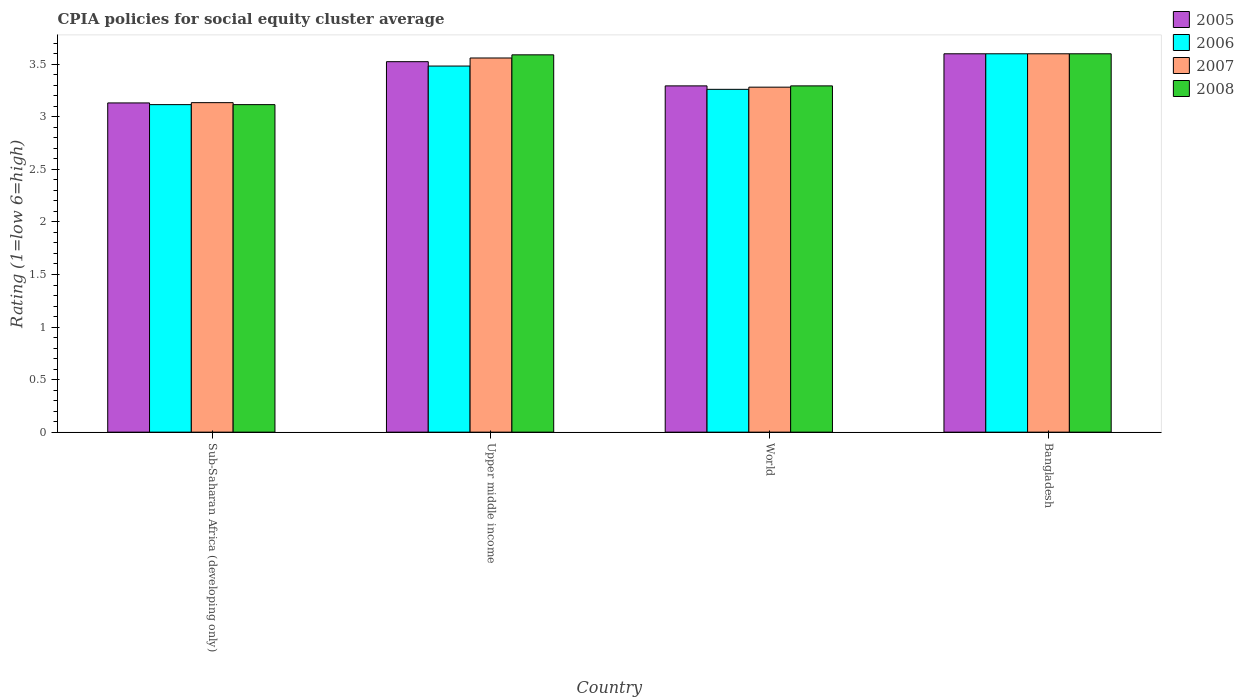How many different coloured bars are there?
Ensure brevity in your answer.  4. How many bars are there on the 4th tick from the left?
Ensure brevity in your answer.  4. How many bars are there on the 2nd tick from the right?
Give a very brief answer. 4. What is the label of the 2nd group of bars from the left?
Offer a terse response. Upper middle income. In how many cases, is the number of bars for a given country not equal to the number of legend labels?
Give a very brief answer. 0. What is the CPIA rating in 2006 in Sub-Saharan Africa (developing only)?
Make the answer very short. 3.12. Across all countries, what is the minimum CPIA rating in 2005?
Ensure brevity in your answer.  3.13. In which country was the CPIA rating in 2008 maximum?
Your response must be concise. Bangladesh. In which country was the CPIA rating in 2005 minimum?
Provide a short and direct response. Sub-Saharan Africa (developing only). What is the total CPIA rating in 2008 in the graph?
Give a very brief answer. 13.6. What is the difference between the CPIA rating in 2006 in Sub-Saharan Africa (developing only) and that in World?
Offer a terse response. -0.15. What is the difference between the CPIA rating in 2008 in World and the CPIA rating in 2006 in Sub-Saharan Africa (developing only)?
Offer a very short reply. 0.18. What is the average CPIA rating in 2006 per country?
Keep it short and to the point. 3.37. What is the difference between the CPIA rating of/in 2007 and CPIA rating of/in 2006 in World?
Offer a very short reply. 0.02. What is the ratio of the CPIA rating in 2007 in Sub-Saharan Africa (developing only) to that in World?
Offer a terse response. 0.96. Is the CPIA rating in 2007 in Bangladesh less than that in World?
Your response must be concise. No. Is the difference between the CPIA rating in 2007 in Bangladesh and Sub-Saharan Africa (developing only) greater than the difference between the CPIA rating in 2006 in Bangladesh and Sub-Saharan Africa (developing only)?
Keep it short and to the point. No. What is the difference between the highest and the second highest CPIA rating in 2005?
Make the answer very short. -0.08. What is the difference between the highest and the lowest CPIA rating in 2006?
Provide a succinct answer. 0.48. In how many countries, is the CPIA rating in 2005 greater than the average CPIA rating in 2005 taken over all countries?
Make the answer very short. 2. What does the 1st bar from the right in Bangladesh represents?
Provide a short and direct response. 2008. Is it the case that in every country, the sum of the CPIA rating in 2005 and CPIA rating in 2007 is greater than the CPIA rating in 2006?
Provide a succinct answer. Yes. How many countries are there in the graph?
Provide a succinct answer. 4. Does the graph contain grids?
Offer a terse response. No. Where does the legend appear in the graph?
Your response must be concise. Top right. How many legend labels are there?
Make the answer very short. 4. How are the legend labels stacked?
Your response must be concise. Vertical. What is the title of the graph?
Your answer should be very brief. CPIA policies for social equity cluster average. Does "1962" appear as one of the legend labels in the graph?
Offer a terse response. No. What is the Rating (1=low 6=high) of 2005 in Sub-Saharan Africa (developing only)?
Keep it short and to the point. 3.13. What is the Rating (1=low 6=high) in 2006 in Sub-Saharan Africa (developing only)?
Provide a succinct answer. 3.12. What is the Rating (1=low 6=high) of 2007 in Sub-Saharan Africa (developing only)?
Your response must be concise. 3.14. What is the Rating (1=low 6=high) in 2008 in Sub-Saharan Africa (developing only)?
Offer a terse response. 3.12. What is the Rating (1=low 6=high) in 2005 in Upper middle income?
Keep it short and to the point. 3.52. What is the Rating (1=low 6=high) of 2006 in Upper middle income?
Your answer should be compact. 3.48. What is the Rating (1=low 6=high) in 2007 in Upper middle income?
Provide a succinct answer. 3.56. What is the Rating (1=low 6=high) in 2008 in Upper middle income?
Offer a very short reply. 3.59. What is the Rating (1=low 6=high) in 2005 in World?
Your answer should be very brief. 3.29. What is the Rating (1=low 6=high) in 2006 in World?
Your answer should be compact. 3.26. What is the Rating (1=low 6=high) of 2007 in World?
Your answer should be compact. 3.28. What is the Rating (1=low 6=high) of 2008 in World?
Your response must be concise. 3.29. Across all countries, what is the maximum Rating (1=low 6=high) in 2005?
Ensure brevity in your answer.  3.6. Across all countries, what is the maximum Rating (1=low 6=high) of 2008?
Your response must be concise. 3.6. Across all countries, what is the minimum Rating (1=low 6=high) of 2005?
Offer a very short reply. 3.13. Across all countries, what is the minimum Rating (1=low 6=high) of 2006?
Keep it short and to the point. 3.12. Across all countries, what is the minimum Rating (1=low 6=high) of 2007?
Keep it short and to the point. 3.14. Across all countries, what is the minimum Rating (1=low 6=high) of 2008?
Provide a succinct answer. 3.12. What is the total Rating (1=low 6=high) of 2005 in the graph?
Offer a very short reply. 13.55. What is the total Rating (1=low 6=high) of 2006 in the graph?
Offer a terse response. 13.46. What is the total Rating (1=low 6=high) in 2007 in the graph?
Your response must be concise. 13.58. What is the total Rating (1=low 6=high) in 2008 in the graph?
Provide a short and direct response. 13.6. What is the difference between the Rating (1=low 6=high) in 2005 in Sub-Saharan Africa (developing only) and that in Upper middle income?
Ensure brevity in your answer.  -0.39. What is the difference between the Rating (1=low 6=high) in 2006 in Sub-Saharan Africa (developing only) and that in Upper middle income?
Your answer should be compact. -0.37. What is the difference between the Rating (1=low 6=high) of 2007 in Sub-Saharan Africa (developing only) and that in Upper middle income?
Your answer should be very brief. -0.42. What is the difference between the Rating (1=low 6=high) of 2008 in Sub-Saharan Africa (developing only) and that in Upper middle income?
Give a very brief answer. -0.47. What is the difference between the Rating (1=low 6=high) in 2005 in Sub-Saharan Africa (developing only) and that in World?
Ensure brevity in your answer.  -0.16. What is the difference between the Rating (1=low 6=high) of 2006 in Sub-Saharan Africa (developing only) and that in World?
Make the answer very short. -0.15. What is the difference between the Rating (1=low 6=high) in 2007 in Sub-Saharan Africa (developing only) and that in World?
Keep it short and to the point. -0.15. What is the difference between the Rating (1=low 6=high) of 2008 in Sub-Saharan Africa (developing only) and that in World?
Offer a terse response. -0.18. What is the difference between the Rating (1=low 6=high) in 2005 in Sub-Saharan Africa (developing only) and that in Bangladesh?
Your answer should be very brief. -0.47. What is the difference between the Rating (1=low 6=high) of 2006 in Sub-Saharan Africa (developing only) and that in Bangladesh?
Give a very brief answer. -0.48. What is the difference between the Rating (1=low 6=high) in 2007 in Sub-Saharan Africa (developing only) and that in Bangladesh?
Give a very brief answer. -0.46. What is the difference between the Rating (1=low 6=high) of 2008 in Sub-Saharan Africa (developing only) and that in Bangladesh?
Offer a terse response. -0.48. What is the difference between the Rating (1=low 6=high) of 2005 in Upper middle income and that in World?
Provide a succinct answer. 0.23. What is the difference between the Rating (1=low 6=high) of 2006 in Upper middle income and that in World?
Your response must be concise. 0.22. What is the difference between the Rating (1=low 6=high) in 2007 in Upper middle income and that in World?
Provide a short and direct response. 0.28. What is the difference between the Rating (1=low 6=high) of 2008 in Upper middle income and that in World?
Provide a succinct answer. 0.3. What is the difference between the Rating (1=low 6=high) in 2005 in Upper middle income and that in Bangladesh?
Your answer should be very brief. -0.07. What is the difference between the Rating (1=low 6=high) in 2006 in Upper middle income and that in Bangladesh?
Offer a very short reply. -0.12. What is the difference between the Rating (1=low 6=high) in 2007 in Upper middle income and that in Bangladesh?
Your answer should be compact. -0.04. What is the difference between the Rating (1=low 6=high) of 2008 in Upper middle income and that in Bangladesh?
Your response must be concise. -0.01. What is the difference between the Rating (1=low 6=high) in 2005 in World and that in Bangladesh?
Your answer should be compact. -0.31. What is the difference between the Rating (1=low 6=high) in 2006 in World and that in Bangladesh?
Offer a very short reply. -0.34. What is the difference between the Rating (1=low 6=high) in 2007 in World and that in Bangladesh?
Your answer should be compact. -0.32. What is the difference between the Rating (1=low 6=high) in 2008 in World and that in Bangladesh?
Make the answer very short. -0.31. What is the difference between the Rating (1=low 6=high) of 2005 in Sub-Saharan Africa (developing only) and the Rating (1=low 6=high) of 2006 in Upper middle income?
Offer a very short reply. -0.35. What is the difference between the Rating (1=low 6=high) in 2005 in Sub-Saharan Africa (developing only) and the Rating (1=low 6=high) in 2007 in Upper middle income?
Ensure brevity in your answer.  -0.43. What is the difference between the Rating (1=low 6=high) in 2005 in Sub-Saharan Africa (developing only) and the Rating (1=low 6=high) in 2008 in Upper middle income?
Ensure brevity in your answer.  -0.46. What is the difference between the Rating (1=low 6=high) in 2006 in Sub-Saharan Africa (developing only) and the Rating (1=low 6=high) in 2007 in Upper middle income?
Offer a terse response. -0.44. What is the difference between the Rating (1=low 6=high) of 2006 in Sub-Saharan Africa (developing only) and the Rating (1=low 6=high) of 2008 in Upper middle income?
Your answer should be compact. -0.47. What is the difference between the Rating (1=low 6=high) of 2007 in Sub-Saharan Africa (developing only) and the Rating (1=low 6=high) of 2008 in Upper middle income?
Offer a terse response. -0.45. What is the difference between the Rating (1=low 6=high) of 2005 in Sub-Saharan Africa (developing only) and the Rating (1=low 6=high) of 2006 in World?
Your answer should be very brief. -0.13. What is the difference between the Rating (1=low 6=high) of 2005 in Sub-Saharan Africa (developing only) and the Rating (1=low 6=high) of 2007 in World?
Ensure brevity in your answer.  -0.15. What is the difference between the Rating (1=low 6=high) of 2005 in Sub-Saharan Africa (developing only) and the Rating (1=low 6=high) of 2008 in World?
Offer a terse response. -0.16. What is the difference between the Rating (1=low 6=high) of 2006 in Sub-Saharan Africa (developing only) and the Rating (1=low 6=high) of 2007 in World?
Ensure brevity in your answer.  -0.17. What is the difference between the Rating (1=low 6=high) of 2006 in Sub-Saharan Africa (developing only) and the Rating (1=low 6=high) of 2008 in World?
Ensure brevity in your answer.  -0.18. What is the difference between the Rating (1=low 6=high) of 2007 in Sub-Saharan Africa (developing only) and the Rating (1=low 6=high) of 2008 in World?
Give a very brief answer. -0.16. What is the difference between the Rating (1=low 6=high) of 2005 in Sub-Saharan Africa (developing only) and the Rating (1=low 6=high) of 2006 in Bangladesh?
Ensure brevity in your answer.  -0.47. What is the difference between the Rating (1=low 6=high) of 2005 in Sub-Saharan Africa (developing only) and the Rating (1=low 6=high) of 2007 in Bangladesh?
Offer a very short reply. -0.47. What is the difference between the Rating (1=low 6=high) in 2005 in Sub-Saharan Africa (developing only) and the Rating (1=low 6=high) in 2008 in Bangladesh?
Offer a terse response. -0.47. What is the difference between the Rating (1=low 6=high) of 2006 in Sub-Saharan Africa (developing only) and the Rating (1=low 6=high) of 2007 in Bangladesh?
Keep it short and to the point. -0.48. What is the difference between the Rating (1=low 6=high) in 2006 in Sub-Saharan Africa (developing only) and the Rating (1=low 6=high) in 2008 in Bangladesh?
Offer a terse response. -0.48. What is the difference between the Rating (1=low 6=high) of 2007 in Sub-Saharan Africa (developing only) and the Rating (1=low 6=high) of 2008 in Bangladesh?
Make the answer very short. -0.46. What is the difference between the Rating (1=low 6=high) in 2005 in Upper middle income and the Rating (1=low 6=high) in 2006 in World?
Offer a very short reply. 0.26. What is the difference between the Rating (1=low 6=high) in 2005 in Upper middle income and the Rating (1=low 6=high) in 2007 in World?
Offer a terse response. 0.24. What is the difference between the Rating (1=low 6=high) of 2005 in Upper middle income and the Rating (1=low 6=high) of 2008 in World?
Your response must be concise. 0.23. What is the difference between the Rating (1=low 6=high) of 2006 in Upper middle income and the Rating (1=low 6=high) of 2007 in World?
Keep it short and to the point. 0.2. What is the difference between the Rating (1=low 6=high) of 2006 in Upper middle income and the Rating (1=low 6=high) of 2008 in World?
Ensure brevity in your answer.  0.19. What is the difference between the Rating (1=low 6=high) in 2007 in Upper middle income and the Rating (1=low 6=high) in 2008 in World?
Ensure brevity in your answer.  0.27. What is the difference between the Rating (1=low 6=high) of 2005 in Upper middle income and the Rating (1=low 6=high) of 2006 in Bangladesh?
Ensure brevity in your answer.  -0.07. What is the difference between the Rating (1=low 6=high) of 2005 in Upper middle income and the Rating (1=low 6=high) of 2007 in Bangladesh?
Give a very brief answer. -0.07. What is the difference between the Rating (1=low 6=high) of 2005 in Upper middle income and the Rating (1=low 6=high) of 2008 in Bangladesh?
Your answer should be compact. -0.07. What is the difference between the Rating (1=low 6=high) in 2006 in Upper middle income and the Rating (1=low 6=high) in 2007 in Bangladesh?
Your response must be concise. -0.12. What is the difference between the Rating (1=low 6=high) of 2006 in Upper middle income and the Rating (1=low 6=high) of 2008 in Bangladesh?
Your response must be concise. -0.12. What is the difference between the Rating (1=low 6=high) of 2007 in Upper middle income and the Rating (1=low 6=high) of 2008 in Bangladesh?
Provide a short and direct response. -0.04. What is the difference between the Rating (1=low 6=high) of 2005 in World and the Rating (1=low 6=high) of 2006 in Bangladesh?
Your response must be concise. -0.31. What is the difference between the Rating (1=low 6=high) of 2005 in World and the Rating (1=low 6=high) of 2007 in Bangladesh?
Keep it short and to the point. -0.31. What is the difference between the Rating (1=low 6=high) of 2005 in World and the Rating (1=low 6=high) of 2008 in Bangladesh?
Your answer should be compact. -0.31. What is the difference between the Rating (1=low 6=high) in 2006 in World and the Rating (1=low 6=high) in 2007 in Bangladesh?
Your response must be concise. -0.34. What is the difference between the Rating (1=low 6=high) in 2006 in World and the Rating (1=low 6=high) in 2008 in Bangladesh?
Provide a succinct answer. -0.34. What is the difference between the Rating (1=low 6=high) of 2007 in World and the Rating (1=low 6=high) of 2008 in Bangladesh?
Provide a succinct answer. -0.32. What is the average Rating (1=low 6=high) of 2005 per country?
Your response must be concise. 3.39. What is the average Rating (1=low 6=high) of 2006 per country?
Provide a succinct answer. 3.37. What is the average Rating (1=low 6=high) of 2007 per country?
Make the answer very short. 3.39. What is the average Rating (1=low 6=high) in 2008 per country?
Your response must be concise. 3.4. What is the difference between the Rating (1=low 6=high) of 2005 and Rating (1=low 6=high) of 2006 in Sub-Saharan Africa (developing only)?
Your answer should be very brief. 0.02. What is the difference between the Rating (1=low 6=high) of 2005 and Rating (1=low 6=high) of 2007 in Sub-Saharan Africa (developing only)?
Provide a short and direct response. -0. What is the difference between the Rating (1=low 6=high) in 2005 and Rating (1=low 6=high) in 2008 in Sub-Saharan Africa (developing only)?
Keep it short and to the point. 0.02. What is the difference between the Rating (1=low 6=high) in 2006 and Rating (1=low 6=high) in 2007 in Sub-Saharan Africa (developing only)?
Offer a terse response. -0.02. What is the difference between the Rating (1=low 6=high) in 2006 and Rating (1=low 6=high) in 2008 in Sub-Saharan Africa (developing only)?
Keep it short and to the point. 0. What is the difference between the Rating (1=low 6=high) of 2007 and Rating (1=low 6=high) of 2008 in Sub-Saharan Africa (developing only)?
Give a very brief answer. 0.02. What is the difference between the Rating (1=low 6=high) of 2005 and Rating (1=low 6=high) of 2006 in Upper middle income?
Your answer should be compact. 0.04. What is the difference between the Rating (1=low 6=high) in 2005 and Rating (1=low 6=high) in 2007 in Upper middle income?
Provide a succinct answer. -0.04. What is the difference between the Rating (1=low 6=high) of 2005 and Rating (1=low 6=high) of 2008 in Upper middle income?
Make the answer very short. -0.07. What is the difference between the Rating (1=low 6=high) of 2006 and Rating (1=low 6=high) of 2007 in Upper middle income?
Offer a terse response. -0.08. What is the difference between the Rating (1=low 6=high) of 2006 and Rating (1=low 6=high) of 2008 in Upper middle income?
Keep it short and to the point. -0.11. What is the difference between the Rating (1=low 6=high) in 2007 and Rating (1=low 6=high) in 2008 in Upper middle income?
Your answer should be very brief. -0.03. What is the difference between the Rating (1=low 6=high) of 2005 and Rating (1=low 6=high) of 2006 in World?
Provide a short and direct response. 0.03. What is the difference between the Rating (1=low 6=high) in 2005 and Rating (1=low 6=high) in 2007 in World?
Keep it short and to the point. 0.01. What is the difference between the Rating (1=low 6=high) of 2005 and Rating (1=low 6=high) of 2008 in World?
Provide a short and direct response. -0. What is the difference between the Rating (1=low 6=high) of 2006 and Rating (1=low 6=high) of 2007 in World?
Give a very brief answer. -0.02. What is the difference between the Rating (1=low 6=high) in 2006 and Rating (1=low 6=high) in 2008 in World?
Make the answer very short. -0.03. What is the difference between the Rating (1=low 6=high) of 2007 and Rating (1=low 6=high) of 2008 in World?
Keep it short and to the point. -0.01. What is the difference between the Rating (1=low 6=high) of 2006 and Rating (1=low 6=high) of 2008 in Bangladesh?
Offer a very short reply. 0. What is the ratio of the Rating (1=low 6=high) of 2005 in Sub-Saharan Africa (developing only) to that in Upper middle income?
Offer a terse response. 0.89. What is the ratio of the Rating (1=low 6=high) in 2006 in Sub-Saharan Africa (developing only) to that in Upper middle income?
Keep it short and to the point. 0.89. What is the ratio of the Rating (1=low 6=high) of 2007 in Sub-Saharan Africa (developing only) to that in Upper middle income?
Offer a very short reply. 0.88. What is the ratio of the Rating (1=low 6=high) of 2008 in Sub-Saharan Africa (developing only) to that in Upper middle income?
Provide a succinct answer. 0.87. What is the ratio of the Rating (1=low 6=high) in 2005 in Sub-Saharan Africa (developing only) to that in World?
Ensure brevity in your answer.  0.95. What is the ratio of the Rating (1=low 6=high) in 2006 in Sub-Saharan Africa (developing only) to that in World?
Ensure brevity in your answer.  0.96. What is the ratio of the Rating (1=low 6=high) of 2007 in Sub-Saharan Africa (developing only) to that in World?
Your answer should be compact. 0.96. What is the ratio of the Rating (1=low 6=high) of 2008 in Sub-Saharan Africa (developing only) to that in World?
Offer a very short reply. 0.95. What is the ratio of the Rating (1=low 6=high) in 2005 in Sub-Saharan Africa (developing only) to that in Bangladesh?
Your response must be concise. 0.87. What is the ratio of the Rating (1=low 6=high) of 2006 in Sub-Saharan Africa (developing only) to that in Bangladesh?
Your response must be concise. 0.87. What is the ratio of the Rating (1=low 6=high) of 2007 in Sub-Saharan Africa (developing only) to that in Bangladesh?
Give a very brief answer. 0.87. What is the ratio of the Rating (1=low 6=high) of 2008 in Sub-Saharan Africa (developing only) to that in Bangladesh?
Offer a very short reply. 0.87. What is the ratio of the Rating (1=low 6=high) of 2005 in Upper middle income to that in World?
Give a very brief answer. 1.07. What is the ratio of the Rating (1=low 6=high) in 2006 in Upper middle income to that in World?
Keep it short and to the point. 1.07. What is the ratio of the Rating (1=low 6=high) of 2007 in Upper middle income to that in World?
Offer a very short reply. 1.08. What is the ratio of the Rating (1=low 6=high) in 2008 in Upper middle income to that in World?
Offer a terse response. 1.09. What is the ratio of the Rating (1=low 6=high) of 2005 in Upper middle income to that in Bangladesh?
Your answer should be compact. 0.98. What is the ratio of the Rating (1=low 6=high) in 2006 in Upper middle income to that in Bangladesh?
Keep it short and to the point. 0.97. What is the ratio of the Rating (1=low 6=high) of 2007 in Upper middle income to that in Bangladesh?
Offer a very short reply. 0.99. What is the ratio of the Rating (1=low 6=high) in 2008 in Upper middle income to that in Bangladesh?
Provide a succinct answer. 1. What is the ratio of the Rating (1=low 6=high) of 2005 in World to that in Bangladesh?
Provide a succinct answer. 0.92. What is the ratio of the Rating (1=low 6=high) of 2006 in World to that in Bangladesh?
Your answer should be very brief. 0.91. What is the ratio of the Rating (1=low 6=high) in 2007 in World to that in Bangladesh?
Your response must be concise. 0.91. What is the ratio of the Rating (1=low 6=high) in 2008 in World to that in Bangladesh?
Offer a very short reply. 0.92. What is the difference between the highest and the second highest Rating (1=low 6=high) in 2005?
Your answer should be compact. 0.07. What is the difference between the highest and the second highest Rating (1=low 6=high) of 2006?
Provide a short and direct response. 0.12. What is the difference between the highest and the second highest Rating (1=low 6=high) in 2007?
Offer a very short reply. 0.04. What is the difference between the highest and the lowest Rating (1=low 6=high) of 2005?
Make the answer very short. 0.47. What is the difference between the highest and the lowest Rating (1=low 6=high) of 2006?
Make the answer very short. 0.48. What is the difference between the highest and the lowest Rating (1=low 6=high) in 2007?
Provide a succinct answer. 0.46. What is the difference between the highest and the lowest Rating (1=low 6=high) of 2008?
Offer a terse response. 0.48. 